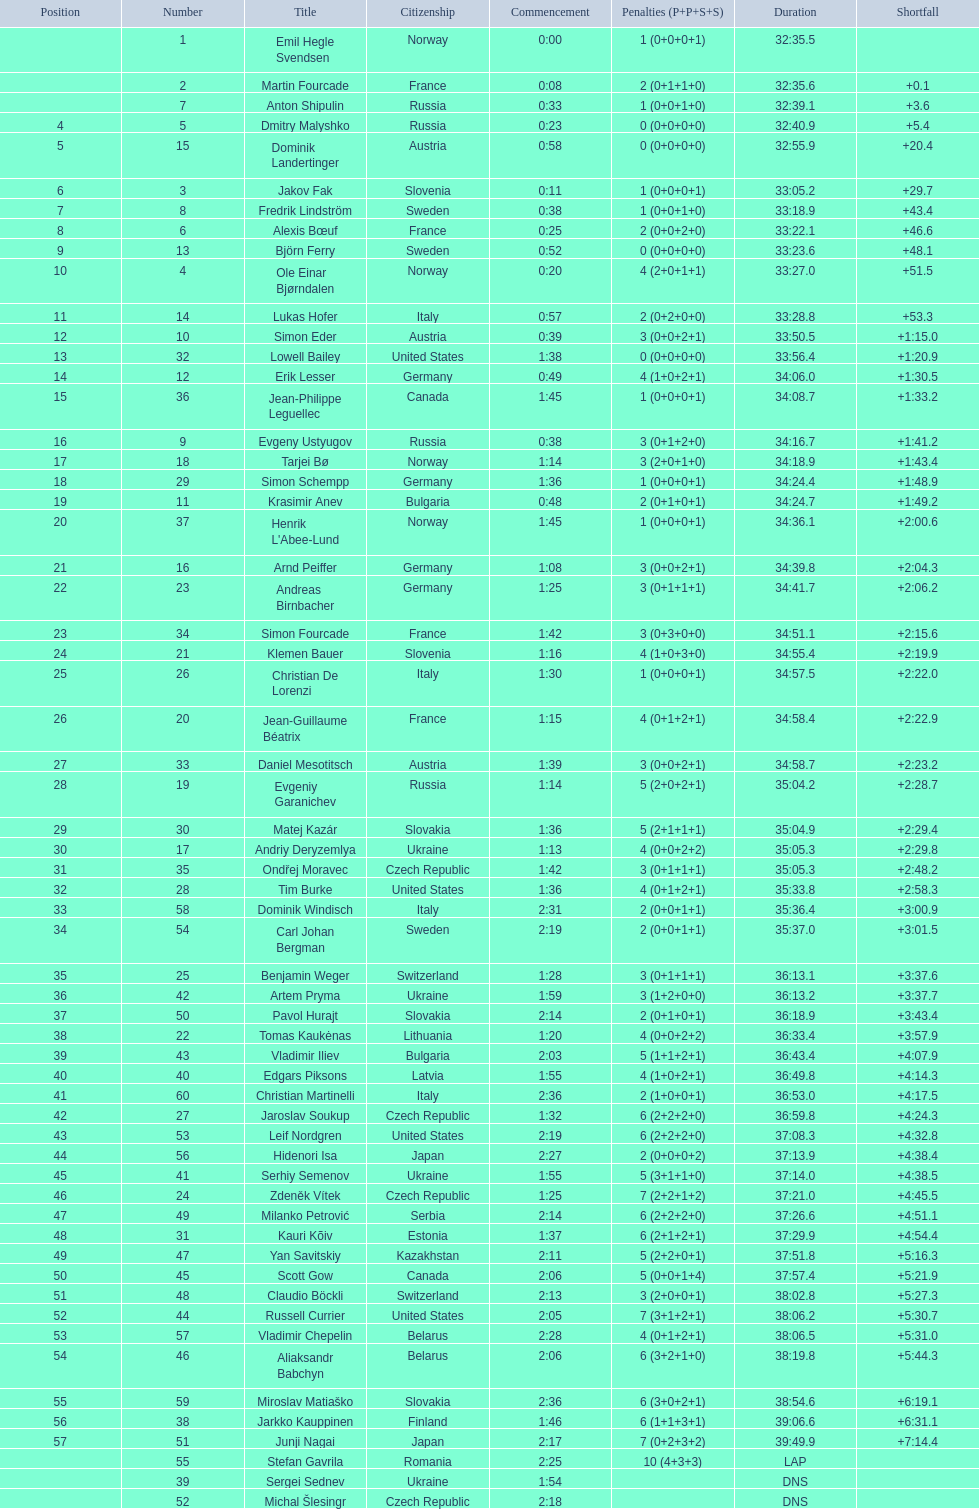Excluding burke, who is another athlete from the united states? Leif Nordgren. 